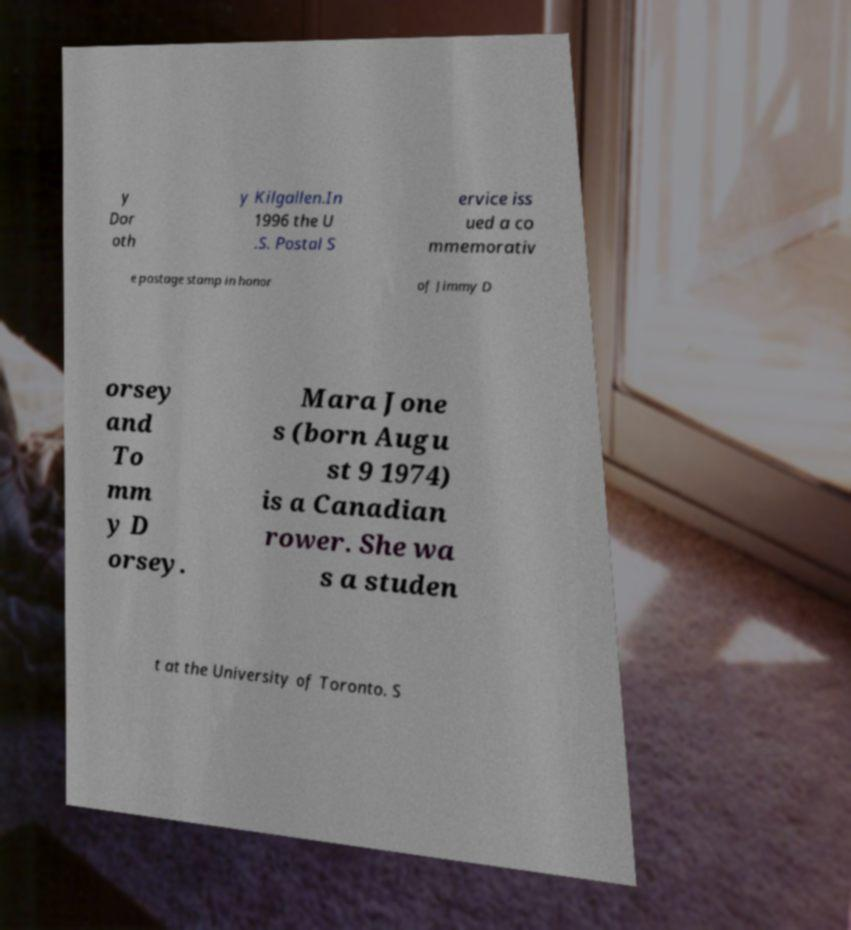For documentation purposes, I need the text within this image transcribed. Could you provide that? y Dor oth y Kilgallen.In 1996 the U .S. Postal S ervice iss ued a co mmemorativ e postage stamp in honor of Jimmy D orsey and To mm y D orsey. Mara Jone s (born Augu st 9 1974) is a Canadian rower. She wa s a studen t at the University of Toronto. S 